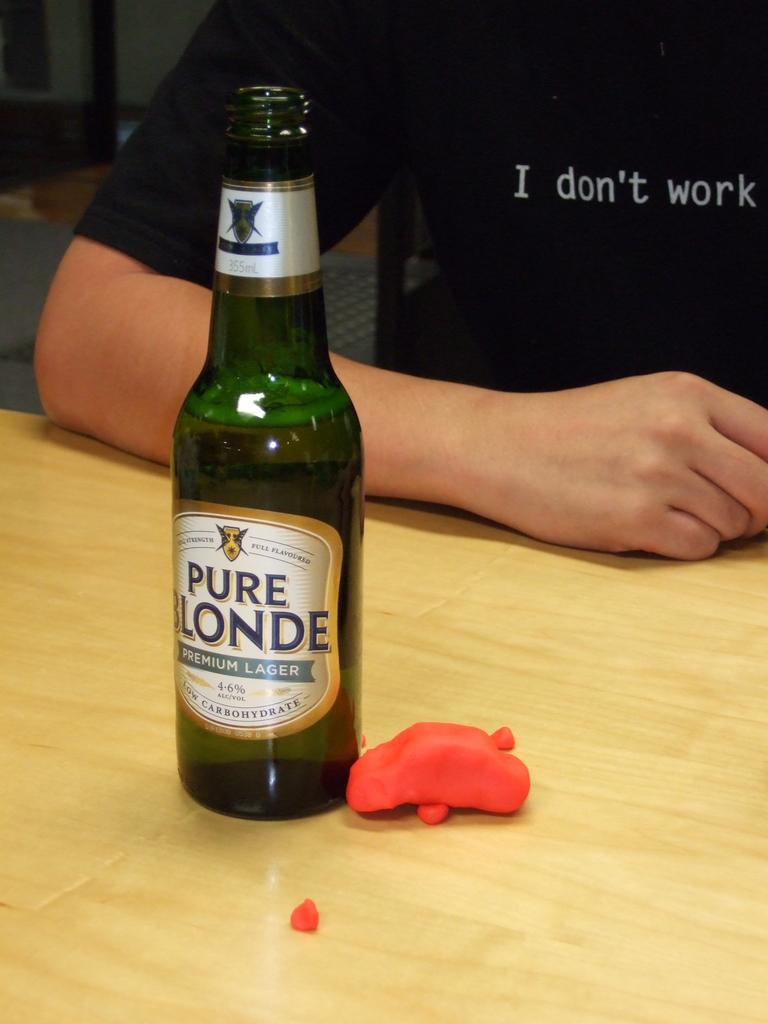What is the alcohol content of this beer?
Provide a short and direct response. 4.6%. 